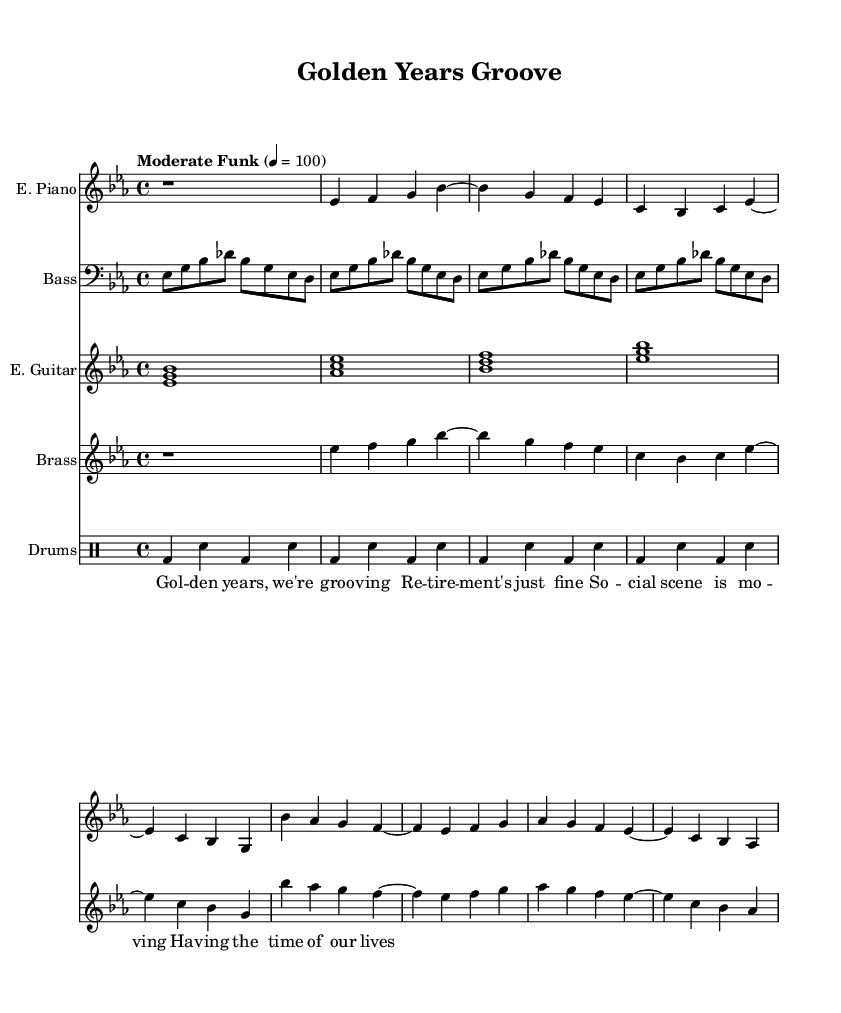What is the key signature of this music? The key signature is E flat major, which has three flats (B flat, E flat, and A flat). This is indicated at the beginning of the staff.
Answer: E flat major What is the time signature of the piece? The time signature is shown at the beginning of the staff and indicates that there are four beats per measure, generally notated as 4/4.
Answer: 4/4 What is the tempo marking for this piece? The tempo marking is written at the beginning of the score and specifies "Moderate Funk" at a metronome marking of 100 beats per minute.
Answer: 100 How many measures are in the electric piano part? By counting each bar in the electric piano stave, there are a total of eight measures; the first is a rest, followed by seven filled measures of notes.
Answer: 8 What main instrument provides the bass line in this piece? The bass part is designated to the bass guitar, indicated by the clef and instrument name on the staff.
Answer: Bass guitar What type of groove is emphasized in the backing vocals? The backing vocals emphasize a fun and enjoyable groove that highlights the theme of enjoying retirement life, as suggested by the lyrics.
Answer: Groove What musical elements signify the piece's 'soul' genre? The piece includes elements typical of soul music like syncopated rhythms and a strong bass line, combined with brass instrumentation and a shared groove, which define its soul character.
Answer: Syncopated rhythms 